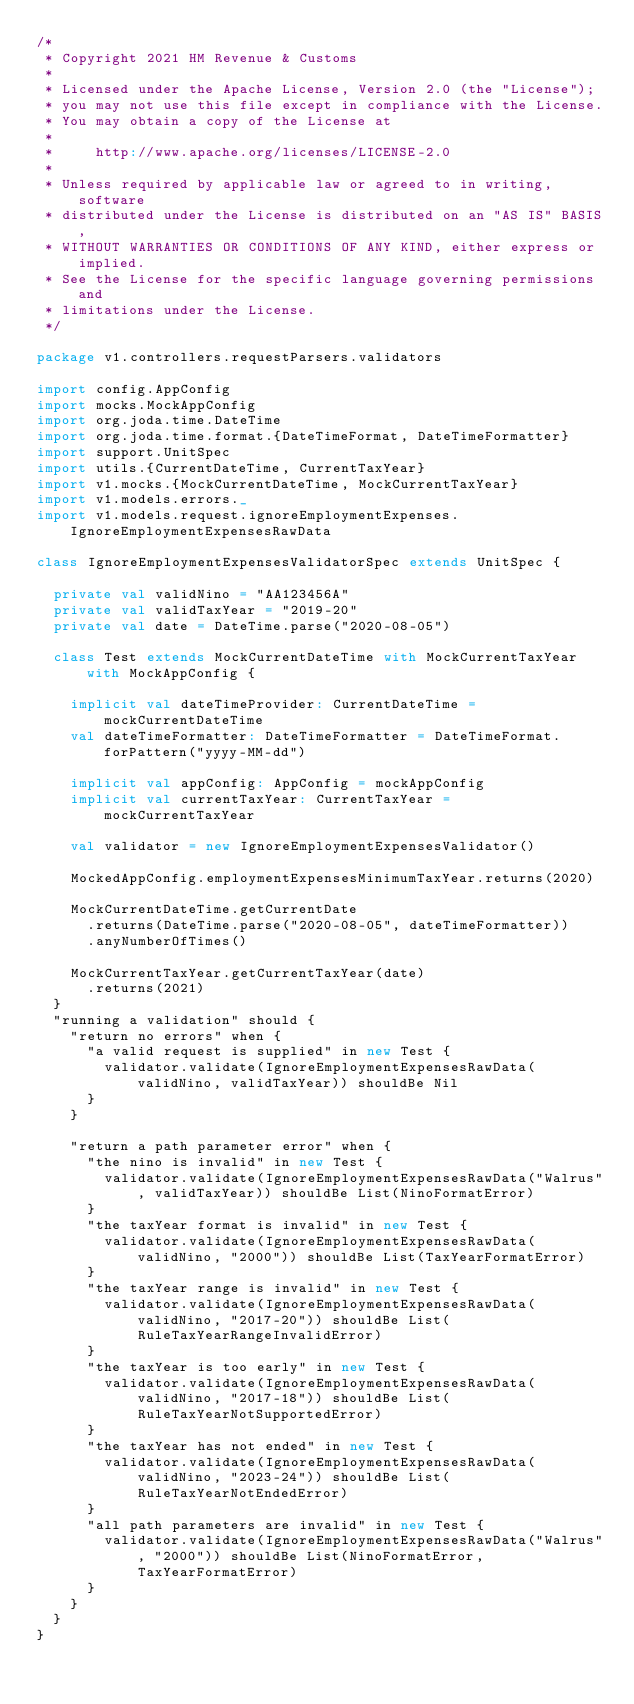Convert code to text. <code><loc_0><loc_0><loc_500><loc_500><_Scala_>/*
 * Copyright 2021 HM Revenue & Customs
 *
 * Licensed under the Apache License, Version 2.0 (the "License");
 * you may not use this file except in compliance with the License.
 * You may obtain a copy of the License at
 *
 *     http://www.apache.org/licenses/LICENSE-2.0
 *
 * Unless required by applicable law or agreed to in writing, software
 * distributed under the License is distributed on an "AS IS" BASIS,
 * WITHOUT WARRANTIES OR CONDITIONS OF ANY KIND, either express or implied.
 * See the License for the specific language governing permissions and
 * limitations under the License.
 */

package v1.controllers.requestParsers.validators

import config.AppConfig
import mocks.MockAppConfig
import org.joda.time.DateTime
import org.joda.time.format.{DateTimeFormat, DateTimeFormatter}
import support.UnitSpec
import utils.{CurrentDateTime, CurrentTaxYear}
import v1.mocks.{MockCurrentDateTime, MockCurrentTaxYear}
import v1.models.errors._
import v1.models.request.ignoreEmploymentExpenses.IgnoreEmploymentExpensesRawData

class IgnoreEmploymentExpensesValidatorSpec extends UnitSpec {

  private val validNino = "AA123456A"
  private val validTaxYear = "2019-20"
  private val date = DateTime.parse("2020-08-05")

  class Test extends MockCurrentDateTime with MockCurrentTaxYear with MockAppConfig {

    implicit val dateTimeProvider: CurrentDateTime = mockCurrentDateTime
    val dateTimeFormatter: DateTimeFormatter = DateTimeFormat.forPattern("yyyy-MM-dd")

    implicit val appConfig: AppConfig = mockAppConfig
    implicit val currentTaxYear: CurrentTaxYear = mockCurrentTaxYear

    val validator = new IgnoreEmploymentExpensesValidator()

    MockedAppConfig.employmentExpensesMinimumTaxYear.returns(2020)

    MockCurrentDateTime.getCurrentDate
      .returns(DateTime.parse("2020-08-05", dateTimeFormatter))
      .anyNumberOfTimes()

    MockCurrentTaxYear.getCurrentTaxYear(date)
      .returns(2021)
  }
  "running a validation" should {
    "return no errors" when {
      "a valid request is supplied" in new Test {
        validator.validate(IgnoreEmploymentExpensesRawData(validNino, validTaxYear)) shouldBe Nil
      }
    }

    "return a path parameter error" when {
      "the nino is invalid" in new Test {
        validator.validate(IgnoreEmploymentExpensesRawData("Walrus", validTaxYear)) shouldBe List(NinoFormatError)
      }
      "the taxYear format is invalid" in new Test {
        validator.validate(IgnoreEmploymentExpensesRawData(validNino, "2000")) shouldBe List(TaxYearFormatError)
      }
      "the taxYear range is invalid" in new Test {
        validator.validate(IgnoreEmploymentExpensesRawData(validNino, "2017-20")) shouldBe List(RuleTaxYearRangeInvalidError)
      }
      "the taxYear is too early" in new Test {
        validator.validate(IgnoreEmploymentExpensesRawData(validNino, "2017-18")) shouldBe List(RuleTaxYearNotSupportedError)
      }
      "the taxYear has not ended" in new Test {
        validator.validate(IgnoreEmploymentExpensesRawData(validNino, "2023-24")) shouldBe List(RuleTaxYearNotEndedError)
      }
      "all path parameters are invalid" in new Test {
        validator.validate(IgnoreEmploymentExpensesRawData("Walrus", "2000")) shouldBe List(NinoFormatError, TaxYearFormatError)
      }
    }
  }
}</code> 